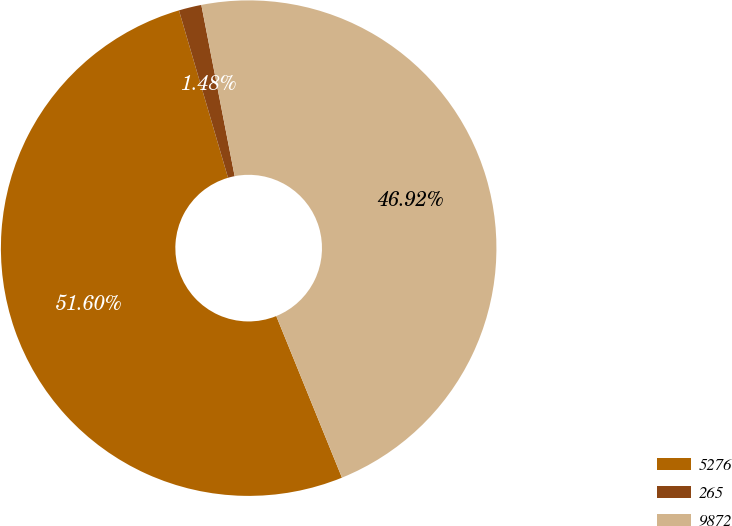Convert chart to OTSL. <chart><loc_0><loc_0><loc_500><loc_500><pie_chart><fcel>5276<fcel>265<fcel>9872<nl><fcel>51.61%<fcel>1.48%<fcel>46.92%<nl></chart> 